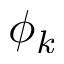Convert formula to latex. <formula><loc_0><loc_0><loc_500><loc_500>\phi _ { k }</formula> 